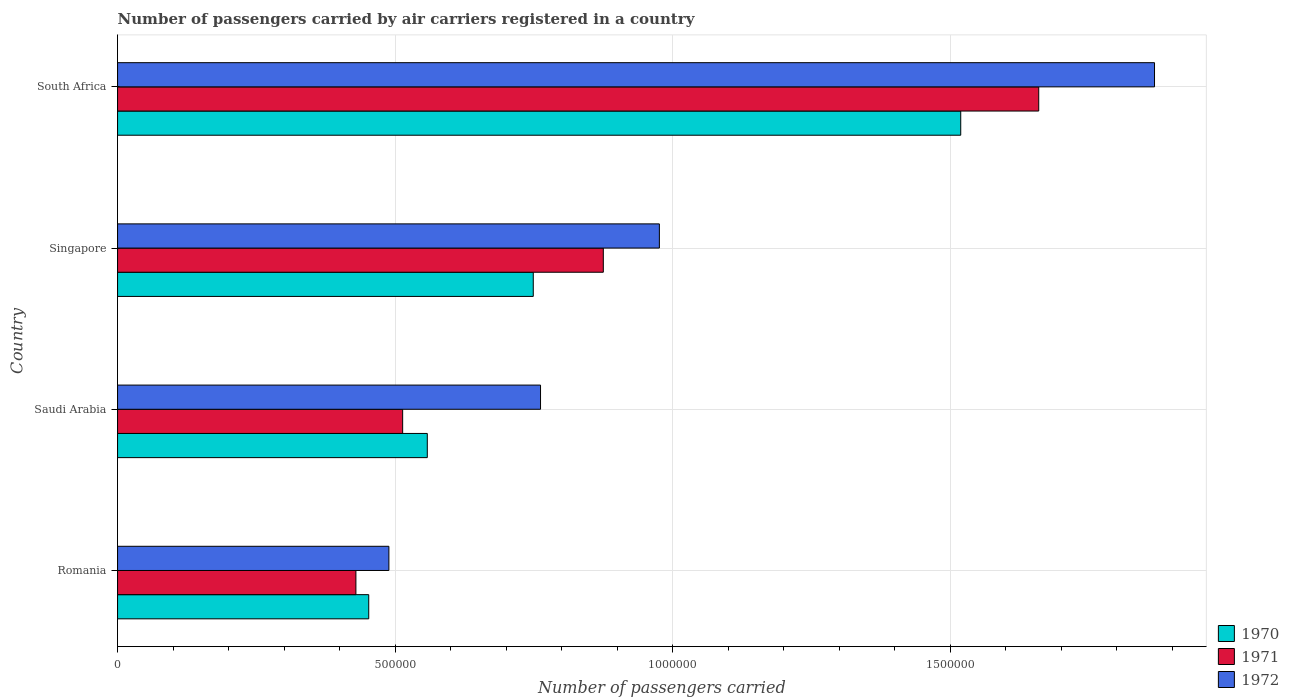Are the number of bars per tick equal to the number of legend labels?
Give a very brief answer. Yes. How many bars are there on the 4th tick from the top?
Your response must be concise. 3. How many bars are there on the 4th tick from the bottom?
Your answer should be very brief. 3. What is the label of the 1st group of bars from the top?
Your answer should be very brief. South Africa. In how many cases, is the number of bars for a given country not equal to the number of legend labels?
Your response must be concise. 0. What is the number of passengers carried by air carriers in 1972 in South Africa?
Offer a terse response. 1.87e+06. Across all countries, what is the maximum number of passengers carried by air carriers in 1971?
Offer a terse response. 1.66e+06. Across all countries, what is the minimum number of passengers carried by air carriers in 1972?
Keep it short and to the point. 4.89e+05. In which country was the number of passengers carried by air carriers in 1971 maximum?
Provide a short and direct response. South Africa. In which country was the number of passengers carried by air carriers in 1971 minimum?
Provide a succinct answer. Romania. What is the total number of passengers carried by air carriers in 1970 in the graph?
Ensure brevity in your answer.  3.28e+06. What is the difference between the number of passengers carried by air carriers in 1972 in Saudi Arabia and that in Singapore?
Offer a terse response. -2.14e+05. What is the difference between the number of passengers carried by air carriers in 1972 in Romania and the number of passengers carried by air carriers in 1971 in South Africa?
Provide a short and direct response. -1.17e+06. What is the average number of passengers carried by air carriers in 1971 per country?
Make the answer very short. 8.69e+05. What is the difference between the number of passengers carried by air carriers in 1971 and number of passengers carried by air carriers in 1970 in Singapore?
Ensure brevity in your answer.  1.26e+05. In how many countries, is the number of passengers carried by air carriers in 1972 greater than 1200000 ?
Make the answer very short. 1. What is the ratio of the number of passengers carried by air carriers in 1971 in Romania to that in South Africa?
Offer a very short reply. 0.26. Is the number of passengers carried by air carriers in 1971 in Singapore less than that in South Africa?
Keep it short and to the point. Yes. What is the difference between the highest and the second highest number of passengers carried by air carriers in 1971?
Provide a short and direct response. 7.84e+05. What is the difference between the highest and the lowest number of passengers carried by air carriers in 1971?
Your answer should be very brief. 1.23e+06. Is it the case that in every country, the sum of the number of passengers carried by air carriers in 1972 and number of passengers carried by air carriers in 1970 is greater than the number of passengers carried by air carriers in 1971?
Your answer should be very brief. Yes. Are all the bars in the graph horizontal?
Offer a terse response. Yes. Are the values on the major ticks of X-axis written in scientific E-notation?
Ensure brevity in your answer.  No. Does the graph contain any zero values?
Ensure brevity in your answer.  No. Does the graph contain grids?
Keep it short and to the point. Yes. Where does the legend appear in the graph?
Keep it short and to the point. Bottom right. How are the legend labels stacked?
Your answer should be compact. Vertical. What is the title of the graph?
Provide a succinct answer. Number of passengers carried by air carriers registered in a country. Does "1979" appear as one of the legend labels in the graph?
Your response must be concise. No. What is the label or title of the X-axis?
Offer a terse response. Number of passengers carried. What is the label or title of the Y-axis?
Your response must be concise. Country. What is the Number of passengers carried of 1970 in Romania?
Give a very brief answer. 4.52e+05. What is the Number of passengers carried in 1971 in Romania?
Your response must be concise. 4.29e+05. What is the Number of passengers carried of 1972 in Romania?
Offer a very short reply. 4.89e+05. What is the Number of passengers carried of 1970 in Saudi Arabia?
Your answer should be compact. 5.58e+05. What is the Number of passengers carried in 1971 in Saudi Arabia?
Give a very brief answer. 5.14e+05. What is the Number of passengers carried in 1972 in Saudi Arabia?
Keep it short and to the point. 7.62e+05. What is the Number of passengers carried in 1970 in Singapore?
Your response must be concise. 7.49e+05. What is the Number of passengers carried in 1971 in Singapore?
Your answer should be compact. 8.75e+05. What is the Number of passengers carried of 1972 in Singapore?
Offer a very short reply. 9.76e+05. What is the Number of passengers carried in 1970 in South Africa?
Keep it short and to the point. 1.52e+06. What is the Number of passengers carried in 1971 in South Africa?
Provide a short and direct response. 1.66e+06. What is the Number of passengers carried of 1972 in South Africa?
Offer a terse response. 1.87e+06. Across all countries, what is the maximum Number of passengers carried of 1970?
Give a very brief answer. 1.52e+06. Across all countries, what is the maximum Number of passengers carried in 1971?
Keep it short and to the point. 1.66e+06. Across all countries, what is the maximum Number of passengers carried of 1972?
Give a very brief answer. 1.87e+06. Across all countries, what is the minimum Number of passengers carried in 1970?
Give a very brief answer. 4.52e+05. Across all countries, what is the minimum Number of passengers carried in 1971?
Make the answer very short. 4.29e+05. Across all countries, what is the minimum Number of passengers carried of 1972?
Give a very brief answer. 4.89e+05. What is the total Number of passengers carried of 1970 in the graph?
Offer a terse response. 3.28e+06. What is the total Number of passengers carried of 1971 in the graph?
Your answer should be very brief. 3.48e+06. What is the total Number of passengers carried in 1972 in the graph?
Keep it short and to the point. 4.10e+06. What is the difference between the Number of passengers carried of 1970 in Romania and that in Saudi Arabia?
Ensure brevity in your answer.  -1.06e+05. What is the difference between the Number of passengers carried in 1971 in Romania and that in Saudi Arabia?
Make the answer very short. -8.42e+04. What is the difference between the Number of passengers carried in 1972 in Romania and that in Saudi Arabia?
Make the answer very short. -2.73e+05. What is the difference between the Number of passengers carried of 1970 in Romania and that in Singapore?
Your response must be concise. -2.96e+05. What is the difference between the Number of passengers carried in 1971 in Romania and that in Singapore?
Make the answer very short. -4.46e+05. What is the difference between the Number of passengers carried in 1972 in Romania and that in Singapore?
Your answer should be very brief. -4.87e+05. What is the difference between the Number of passengers carried in 1970 in Romania and that in South Africa?
Your answer should be very brief. -1.07e+06. What is the difference between the Number of passengers carried of 1971 in Romania and that in South Africa?
Provide a short and direct response. -1.23e+06. What is the difference between the Number of passengers carried of 1972 in Romania and that in South Africa?
Make the answer very short. -1.38e+06. What is the difference between the Number of passengers carried of 1970 in Saudi Arabia and that in Singapore?
Give a very brief answer. -1.91e+05. What is the difference between the Number of passengers carried in 1971 in Saudi Arabia and that in Singapore?
Make the answer very short. -3.62e+05. What is the difference between the Number of passengers carried of 1972 in Saudi Arabia and that in Singapore?
Make the answer very short. -2.14e+05. What is the difference between the Number of passengers carried of 1970 in Saudi Arabia and that in South Africa?
Ensure brevity in your answer.  -9.61e+05. What is the difference between the Number of passengers carried of 1971 in Saudi Arabia and that in South Africa?
Your answer should be very brief. -1.15e+06. What is the difference between the Number of passengers carried in 1972 in Saudi Arabia and that in South Africa?
Provide a short and direct response. -1.11e+06. What is the difference between the Number of passengers carried of 1970 in Singapore and that in South Africa?
Offer a very short reply. -7.70e+05. What is the difference between the Number of passengers carried of 1971 in Singapore and that in South Africa?
Offer a very short reply. -7.84e+05. What is the difference between the Number of passengers carried of 1972 in Singapore and that in South Africa?
Provide a short and direct response. -8.92e+05. What is the difference between the Number of passengers carried of 1970 in Romania and the Number of passengers carried of 1971 in Saudi Arabia?
Offer a very short reply. -6.11e+04. What is the difference between the Number of passengers carried of 1970 in Romania and the Number of passengers carried of 1972 in Saudi Arabia?
Make the answer very short. -3.10e+05. What is the difference between the Number of passengers carried of 1971 in Romania and the Number of passengers carried of 1972 in Saudi Arabia?
Offer a terse response. -3.33e+05. What is the difference between the Number of passengers carried in 1970 in Romania and the Number of passengers carried in 1971 in Singapore?
Your answer should be compact. -4.23e+05. What is the difference between the Number of passengers carried of 1970 in Romania and the Number of passengers carried of 1972 in Singapore?
Your answer should be very brief. -5.24e+05. What is the difference between the Number of passengers carried in 1971 in Romania and the Number of passengers carried in 1972 in Singapore?
Your answer should be very brief. -5.47e+05. What is the difference between the Number of passengers carried of 1970 in Romania and the Number of passengers carried of 1971 in South Africa?
Provide a short and direct response. -1.21e+06. What is the difference between the Number of passengers carried of 1970 in Romania and the Number of passengers carried of 1972 in South Africa?
Give a very brief answer. -1.42e+06. What is the difference between the Number of passengers carried in 1971 in Romania and the Number of passengers carried in 1972 in South Africa?
Ensure brevity in your answer.  -1.44e+06. What is the difference between the Number of passengers carried of 1970 in Saudi Arabia and the Number of passengers carried of 1971 in Singapore?
Provide a short and direct response. -3.17e+05. What is the difference between the Number of passengers carried in 1970 in Saudi Arabia and the Number of passengers carried in 1972 in Singapore?
Provide a short and direct response. -4.18e+05. What is the difference between the Number of passengers carried in 1971 in Saudi Arabia and the Number of passengers carried in 1972 in Singapore?
Your answer should be very brief. -4.62e+05. What is the difference between the Number of passengers carried of 1970 in Saudi Arabia and the Number of passengers carried of 1971 in South Africa?
Give a very brief answer. -1.10e+06. What is the difference between the Number of passengers carried of 1970 in Saudi Arabia and the Number of passengers carried of 1972 in South Africa?
Make the answer very short. -1.31e+06. What is the difference between the Number of passengers carried in 1971 in Saudi Arabia and the Number of passengers carried in 1972 in South Africa?
Ensure brevity in your answer.  -1.35e+06. What is the difference between the Number of passengers carried in 1970 in Singapore and the Number of passengers carried in 1971 in South Africa?
Your answer should be very brief. -9.11e+05. What is the difference between the Number of passengers carried in 1970 in Singapore and the Number of passengers carried in 1972 in South Africa?
Your response must be concise. -1.12e+06. What is the difference between the Number of passengers carried in 1971 in Singapore and the Number of passengers carried in 1972 in South Africa?
Your answer should be very brief. -9.93e+05. What is the average Number of passengers carried of 1970 per country?
Offer a very short reply. 8.20e+05. What is the average Number of passengers carried in 1971 per country?
Make the answer very short. 8.69e+05. What is the average Number of passengers carried in 1972 per country?
Make the answer very short. 1.02e+06. What is the difference between the Number of passengers carried of 1970 and Number of passengers carried of 1971 in Romania?
Keep it short and to the point. 2.31e+04. What is the difference between the Number of passengers carried in 1970 and Number of passengers carried in 1972 in Romania?
Offer a very short reply. -3.63e+04. What is the difference between the Number of passengers carried in 1971 and Number of passengers carried in 1972 in Romania?
Make the answer very short. -5.94e+04. What is the difference between the Number of passengers carried of 1970 and Number of passengers carried of 1971 in Saudi Arabia?
Ensure brevity in your answer.  4.44e+04. What is the difference between the Number of passengers carried of 1970 and Number of passengers carried of 1972 in Saudi Arabia?
Your answer should be compact. -2.04e+05. What is the difference between the Number of passengers carried of 1971 and Number of passengers carried of 1972 in Saudi Arabia?
Provide a succinct answer. -2.48e+05. What is the difference between the Number of passengers carried of 1970 and Number of passengers carried of 1971 in Singapore?
Provide a succinct answer. -1.26e+05. What is the difference between the Number of passengers carried in 1970 and Number of passengers carried in 1972 in Singapore?
Your response must be concise. -2.27e+05. What is the difference between the Number of passengers carried of 1971 and Number of passengers carried of 1972 in Singapore?
Make the answer very short. -1.01e+05. What is the difference between the Number of passengers carried of 1970 and Number of passengers carried of 1971 in South Africa?
Offer a very short reply. -1.40e+05. What is the difference between the Number of passengers carried of 1970 and Number of passengers carried of 1972 in South Africa?
Your answer should be compact. -3.49e+05. What is the difference between the Number of passengers carried of 1971 and Number of passengers carried of 1972 in South Africa?
Your answer should be very brief. -2.09e+05. What is the ratio of the Number of passengers carried of 1970 in Romania to that in Saudi Arabia?
Your answer should be compact. 0.81. What is the ratio of the Number of passengers carried in 1971 in Romania to that in Saudi Arabia?
Provide a short and direct response. 0.84. What is the ratio of the Number of passengers carried of 1972 in Romania to that in Saudi Arabia?
Ensure brevity in your answer.  0.64. What is the ratio of the Number of passengers carried in 1970 in Romania to that in Singapore?
Keep it short and to the point. 0.6. What is the ratio of the Number of passengers carried of 1971 in Romania to that in Singapore?
Make the answer very short. 0.49. What is the ratio of the Number of passengers carried of 1972 in Romania to that in Singapore?
Your answer should be compact. 0.5. What is the ratio of the Number of passengers carried of 1970 in Romania to that in South Africa?
Keep it short and to the point. 0.3. What is the ratio of the Number of passengers carried of 1971 in Romania to that in South Africa?
Provide a succinct answer. 0.26. What is the ratio of the Number of passengers carried in 1972 in Romania to that in South Africa?
Keep it short and to the point. 0.26. What is the ratio of the Number of passengers carried in 1970 in Saudi Arabia to that in Singapore?
Provide a succinct answer. 0.75. What is the ratio of the Number of passengers carried of 1971 in Saudi Arabia to that in Singapore?
Offer a terse response. 0.59. What is the ratio of the Number of passengers carried of 1972 in Saudi Arabia to that in Singapore?
Give a very brief answer. 0.78. What is the ratio of the Number of passengers carried in 1970 in Saudi Arabia to that in South Africa?
Offer a very short reply. 0.37. What is the ratio of the Number of passengers carried of 1971 in Saudi Arabia to that in South Africa?
Provide a succinct answer. 0.31. What is the ratio of the Number of passengers carried of 1972 in Saudi Arabia to that in South Africa?
Your answer should be compact. 0.41. What is the ratio of the Number of passengers carried of 1970 in Singapore to that in South Africa?
Ensure brevity in your answer.  0.49. What is the ratio of the Number of passengers carried in 1971 in Singapore to that in South Africa?
Ensure brevity in your answer.  0.53. What is the ratio of the Number of passengers carried of 1972 in Singapore to that in South Africa?
Offer a very short reply. 0.52. What is the difference between the highest and the second highest Number of passengers carried of 1970?
Make the answer very short. 7.70e+05. What is the difference between the highest and the second highest Number of passengers carried of 1971?
Offer a terse response. 7.84e+05. What is the difference between the highest and the second highest Number of passengers carried in 1972?
Your answer should be compact. 8.92e+05. What is the difference between the highest and the lowest Number of passengers carried of 1970?
Provide a succinct answer. 1.07e+06. What is the difference between the highest and the lowest Number of passengers carried of 1971?
Give a very brief answer. 1.23e+06. What is the difference between the highest and the lowest Number of passengers carried of 1972?
Your answer should be compact. 1.38e+06. 